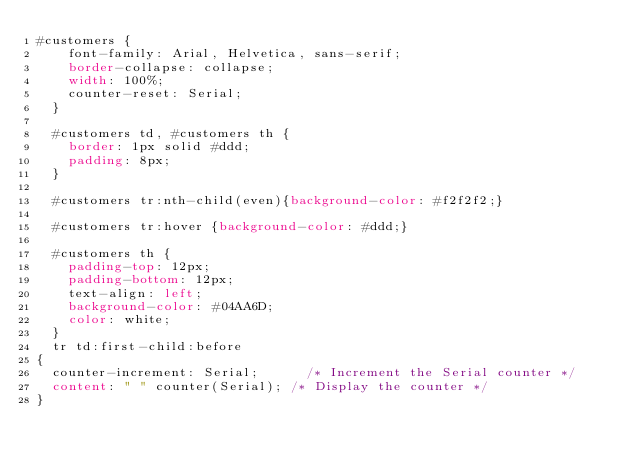<code> <loc_0><loc_0><loc_500><loc_500><_CSS_>#customers {
    font-family: Arial, Helvetica, sans-serif;
    border-collapse: collapse;
    width: 100%;
    counter-reset: Serial; 
  }
  
  #customers td, #customers th {
    border: 1px solid #ddd;
    padding: 8px;
  }
  
  #customers tr:nth-child(even){background-color: #f2f2f2;}
  
  #customers tr:hover {background-color: #ddd;}
  
  #customers th {
    padding-top: 12px;
    padding-bottom: 12px;
    text-align: left;
    background-color: #04AA6D;
    color: white;
  }
  tr td:first-child:before
{
  counter-increment: Serial;      /* Increment the Serial counter */
  content: " " counter(Serial); /* Display the counter */
}</code> 